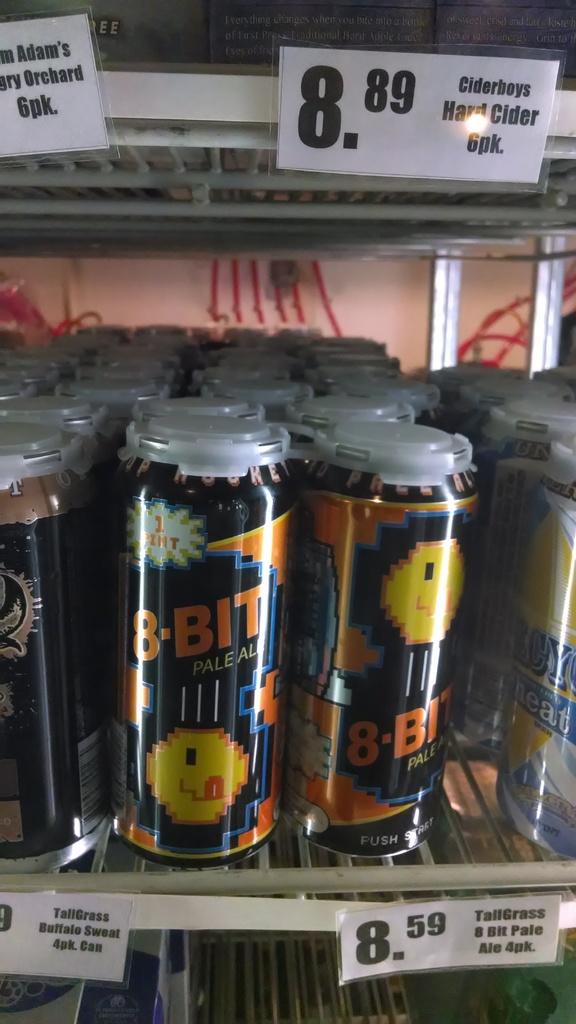What is the price of the cans on the lower shelf?
Your response must be concise. 8.59. What brand of beer?
Keep it short and to the point. 8 bit. 